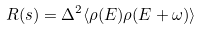Convert formula to latex. <formula><loc_0><loc_0><loc_500><loc_500>R ( s ) = \Delta ^ { 2 } \langle \rho ( E ) \rho ( E + \omega ) \rangle</formula> 